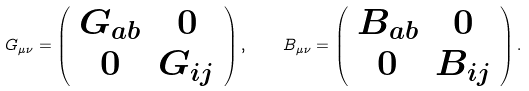<formula> <loc_0><loc_0><loc_500><loc_500>G _ { \mu \nu } = \left ( \begin{array} { c c } G _ { a b } & 0 \\ 0 & G _ { i j } \end{array} \right ) , \quad B _ { \mu \nu } = \left ( \begin{array} { c c } B _ { a b } & 0 \\ 0 & B _ { i j } \end{array} \right ) .</formula> 